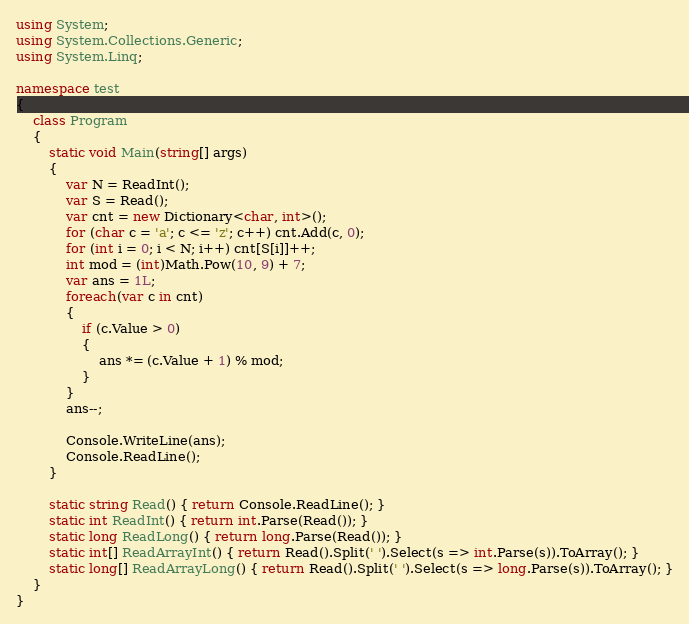Convert code to text. <code><loc_0><loc_0><loc_500><loc_500><_C#_>using System;
using System.Collections.Generic;
using System.Linq;

namespace test
{
    class Program
    {
        static void Main(string[] args)
        {
            var N = ReadInt();
            var S = Read();
            var cnt = new Dictionary<char, int>();
            for (char c = 'a'; c <= 'z'; c++) cnt.Add(c, 0);
            for (int i = 0; i < N; i++) cnt[S[i]]++;
            int mod = (int)Math.Pow(10, 9) + 7;
            var ans = 1L;
            foreach(var c in cnt)
            {
                if (c.Value > 0)
                {
                    ans *= (c.Value + 1) % mod;
                }
            }
            ans--;

            Console.WriteLine(ans);
            Console.ReadLine();
        }

        static string Read() { return Console.ReadLine(); }
        static int ReadInt() { return int.Parse(Read()); }
        static long ReadLong() { return long.Parse(Read()); }
        static int[] ReadArrayInt() { return Read().Split(' ').Select(s => int.Parse(s)).ToArray(); }
        static long[] ReadArrayLong() { return Read().Split(' ').Select(s => long.Parse(s)).ToArray(); }
    }
}</code> 